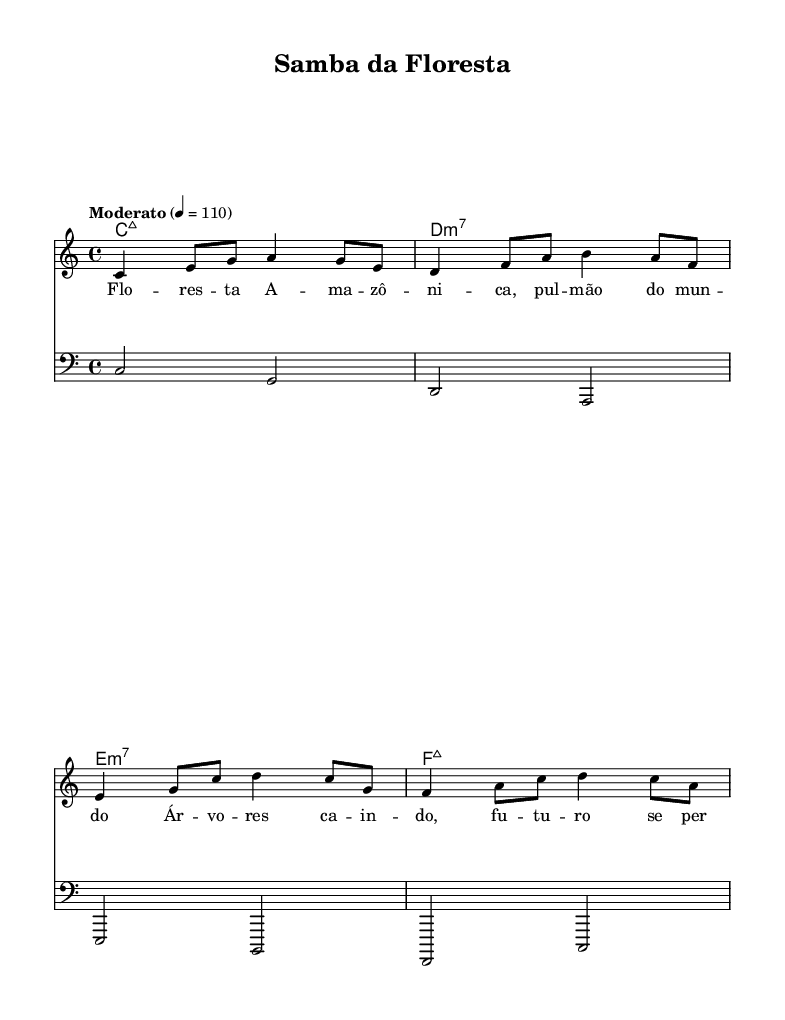What is the key signature of this music? The key signature is C major, which is indicated by the absence of any sharps or flats in the music.
Answer: C major What is the time signature of this piece? The time signature is indicated at the beginning of the score, shown as 4/4, meaning there are four beats in each measure and the quarter note gets one beat.
Answer: 4/4 What is the tempo marking for this piece? The tempo marking is mentioned as "Moderato" with a metronome marking of 110, suggesting a moderate speed for the music.
Answer: Moderato How many measures does the melody contain? The melody consists of four measures, which can be counted by examining the individual segments of music separated by vertical bar lines.
Answer: 4 What type of song is "Samba da Floresta"? The song "Samba da Floresta" is classified as Bossa Nova, a Brazilian music genre characterized by its samba and jazz influences, which reflects the environmental themes present in the lyrics.
Answer: Bossa Nova What do the lyrics refer to in this song? The lyrics in "Samba da Floresta" refer to preserving the Amazon, emphasizing the call to action against deforestation and recognizing the forest's vital role in the world.
Answer: Amazon What is the root chord of the first measure? The root chord of the first measure is C major 7, as notated in the chord names section, which indicates the harmonic foundation for that section of the music.
Answer: Cmaj7 